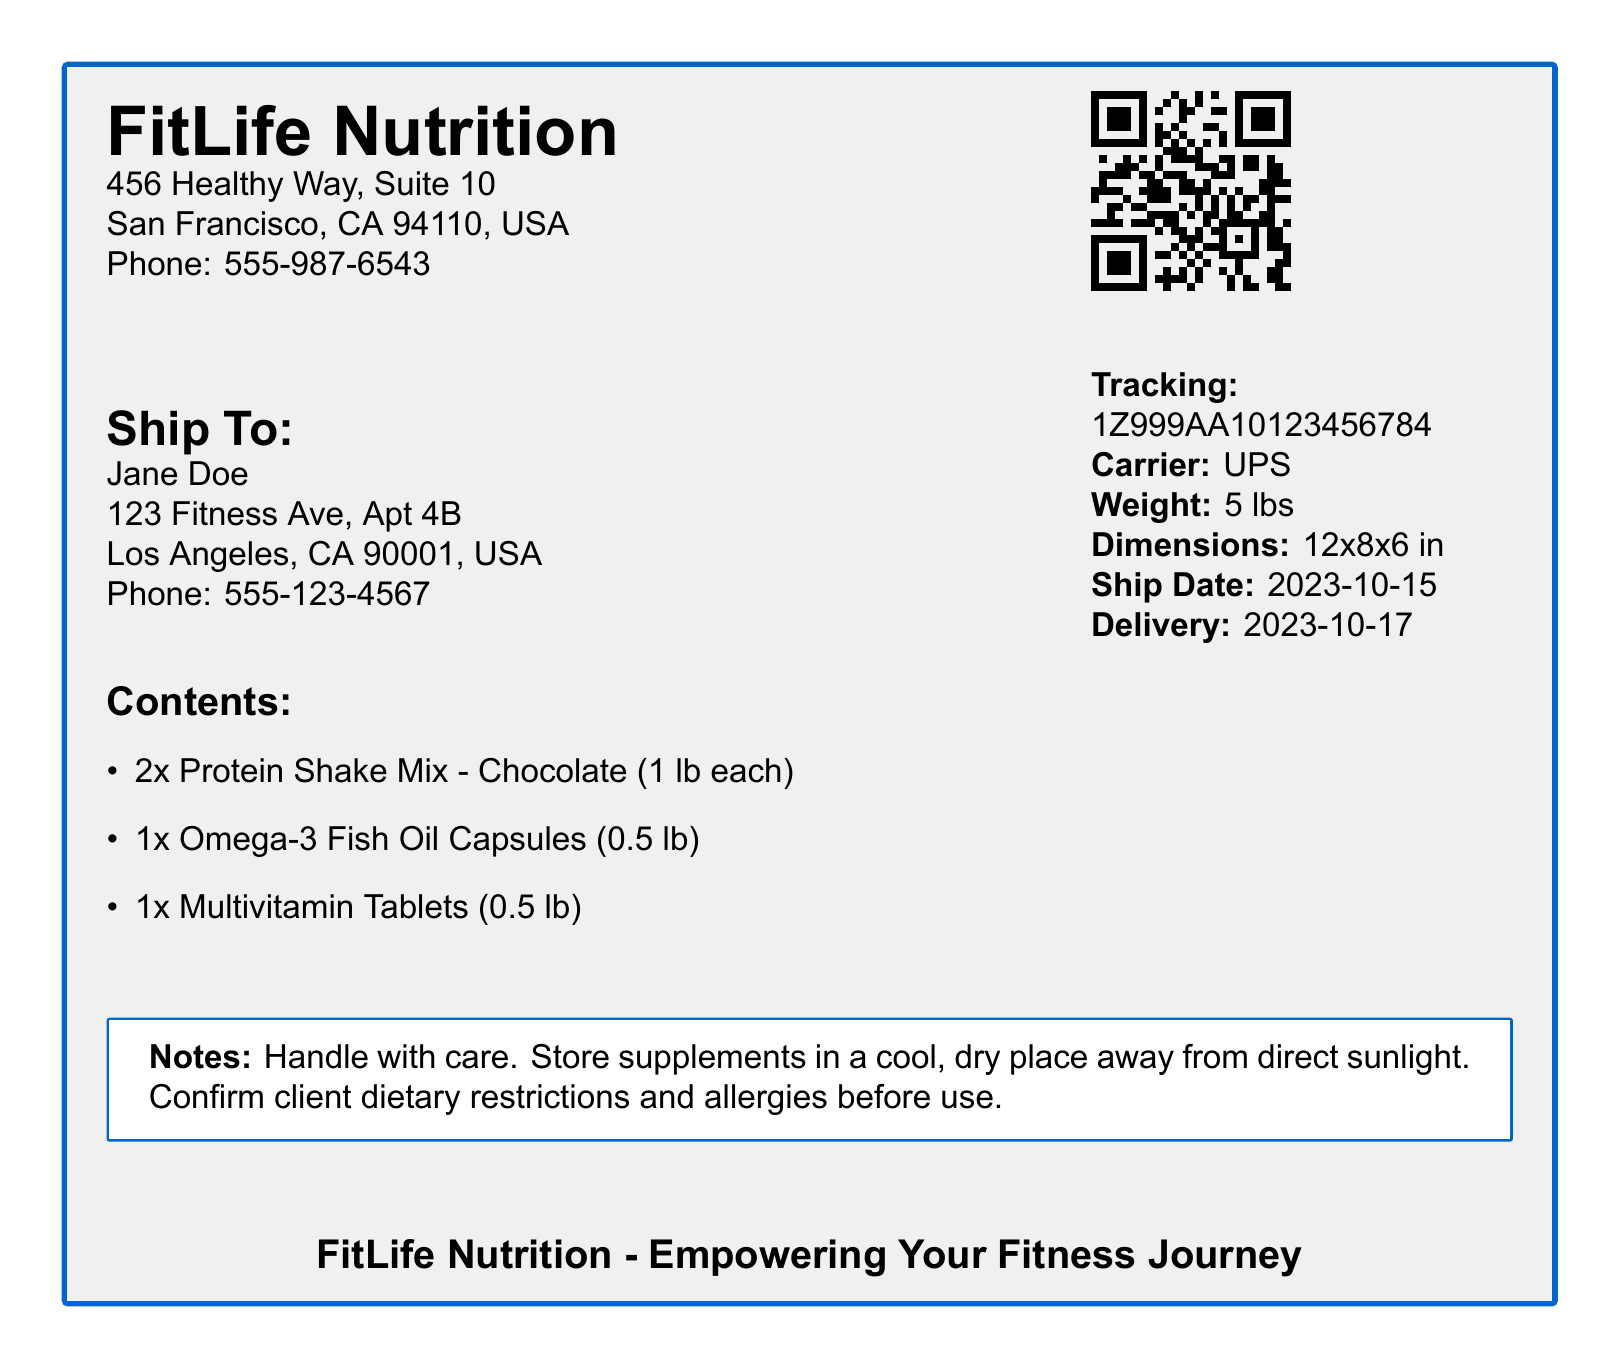What is the company name? The company name is prominently displayed at the top of the document as "FitLife Nutrition."
Answer: FitLife Nutrition What is the phone number of the sender? The sender's phone number is listed under the company details.
Answer: 555-987-6543 Who is the recipient? The recipient's name is located under the "Ship To:" section.
Answer: Jane Doe What is the tracking number? The tracking number is provided in the information section on the right side of the document.
Answer: 1Z999AA10123456784 On what date was the shipment made? The ship date is indicated in the shipment details.
Answer: 2023-10-15 What is the total weight of the shipment? The total weight can be found in the shipping details section.
Answer: 5 lbs How many Protein Shake Mixes are included in the shipment? The contents of the shipment specify the number of Protein Shake Mixes included.
Answer: 2x What should be done with the supplements regarding storage? This information is found in the notes section of the document.
Answer: Store in a cool, dry place What is the carrier used for the shipment? The carrier's name is displayed in the shipment details section.
Answer: UPS What is the delivery date? The delivery date is mentioned in the shipment information on the right side of the document.
Answer: 2023-10-17 